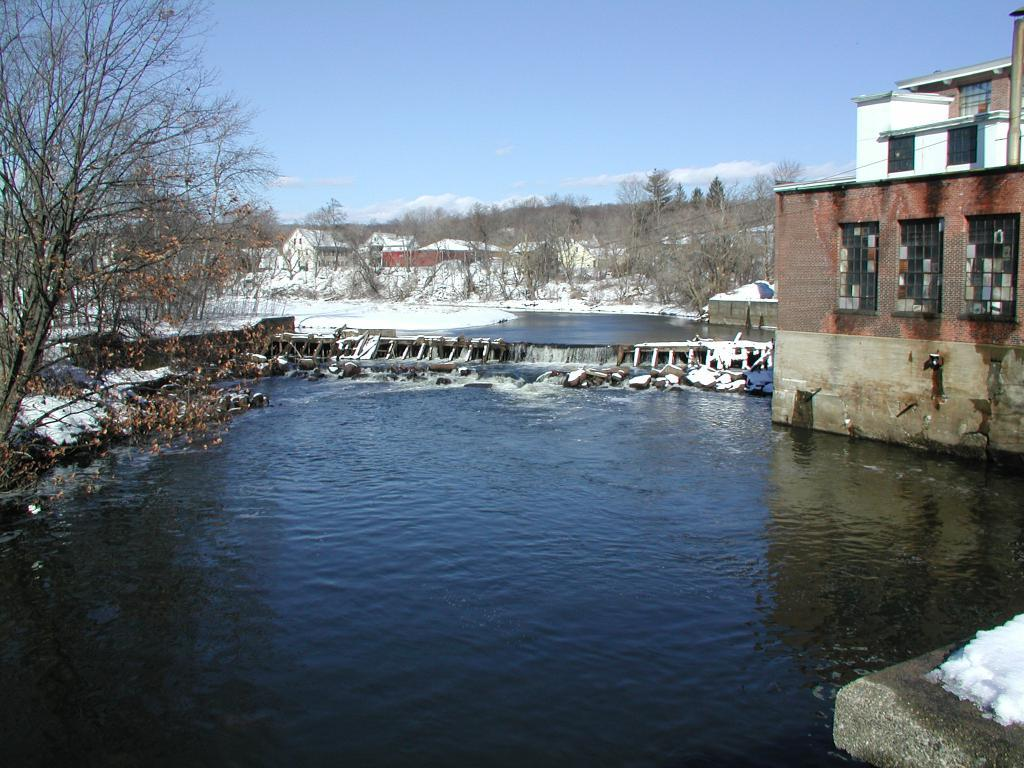What type of structures can be seen in the image? There are buildings in the image. What feature is visible on the buildings? There are windows visible in the image. What type of natural elements can be seen in the image? There are trees and water visible in the image. What is the color of the sky in the image? The sky is blue and white in color. What type of competition is taking place in the image? There is no competition present in the image. Can you see a train in the image? There is no train visible in the image. 